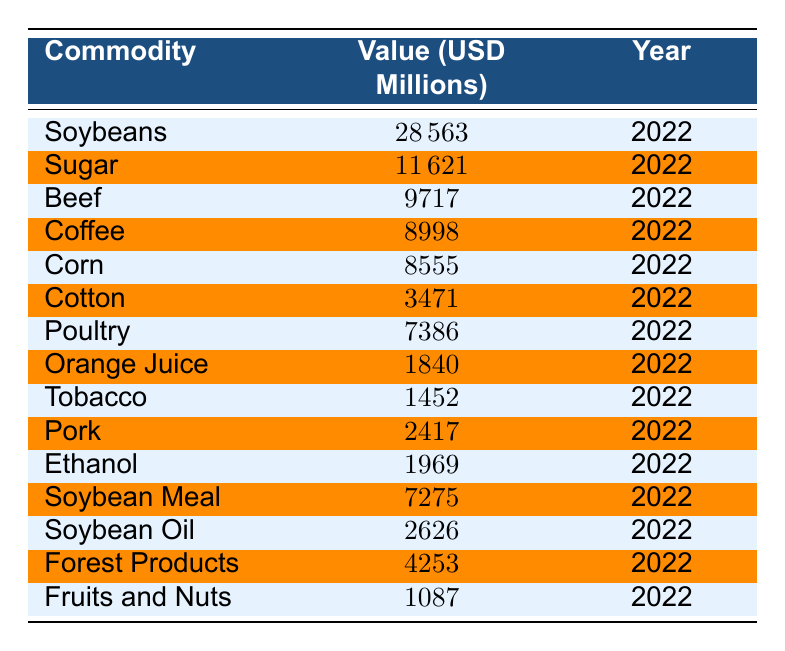What is the value of Brazil's soybean exports in 2022? The table clearly shows the row for soybeans, listing its value as 28563 million USD for the year 2022.
Answer: 28563 million USD Which commodity had the highest export value in 2022? Looking through the table, soybeans are listed with the highest value of 28563 million USD, making them the leader in export value for 2022.
Answer: Soybeans What is the total value of sugar and coffee exports combined? To find the total value, we add the export values: sugar (11621 million USD) plus coffee (8998 million USD) equals 20619 million USD.
Answer: 20619 million USD Is the export value of beef greater than that of orange juice? The value of beef is stated as 9717 million USD, while the value of orange juice is 1840 million USD. Since 9717 is greater than 1840, the answer is yes.
Answer: Yes What is the average value of Brazil's top three agricultural exports? The top three exports by value are soybeans (28563 million USD), sugar (11621 million USD), and beef (9717 million USD). Adding them: 28563 + 11621 + 9717 = 49901 million USD. Dividing by 3 gives an average of 16633.67 million USD.
Answer: 16633.67 million USD How much more was earned from poultry exports compared to tobacco exports? Poultry exports were valued at 7386 million USD and tobacco exports at 1452 million USD. The difference is calculated by subtracting tobacco's value from poultry’s: 7386 - 1452 equals 5934 million USD.
Answer: 5934 million USD What percentage of the total agricultural export value does corn represent? First, we sum up all the export values to find the total. The total is 28563 + 11621 + 9717 + 8998 + 8555 + 3471 + 7386 + 1840 + 1452 + 2417 + 1969 + 7275 + 2626 + 4253 + 1087 =  61575 million USD. Corn's export value is 8555 million USD, so we calculate the percentage: (8555 / 61575) * 100, which is approximately 13.87%.
Answer: 13.87% Did Brazil export more value in fruits and nuts compared to ethanol in 2022? The table states that fruits and nuts were valued at 1087 million USD and ethanol at 1969 million USD. Since 1087 is less than 1969, the answer is no.
Answer: No What is the total value of Brazil's agricultural exports from cereals (corn) and oilseeds (soybeans and soybean oil)? The totals for corn are 8555 million USD, for soybeans 28563 million USD, and for soybean oil 2626 million USD. Adding these values together: 8555 + 28563 + 2626 = 39744 million USD.
Answer: 39744 million USD 